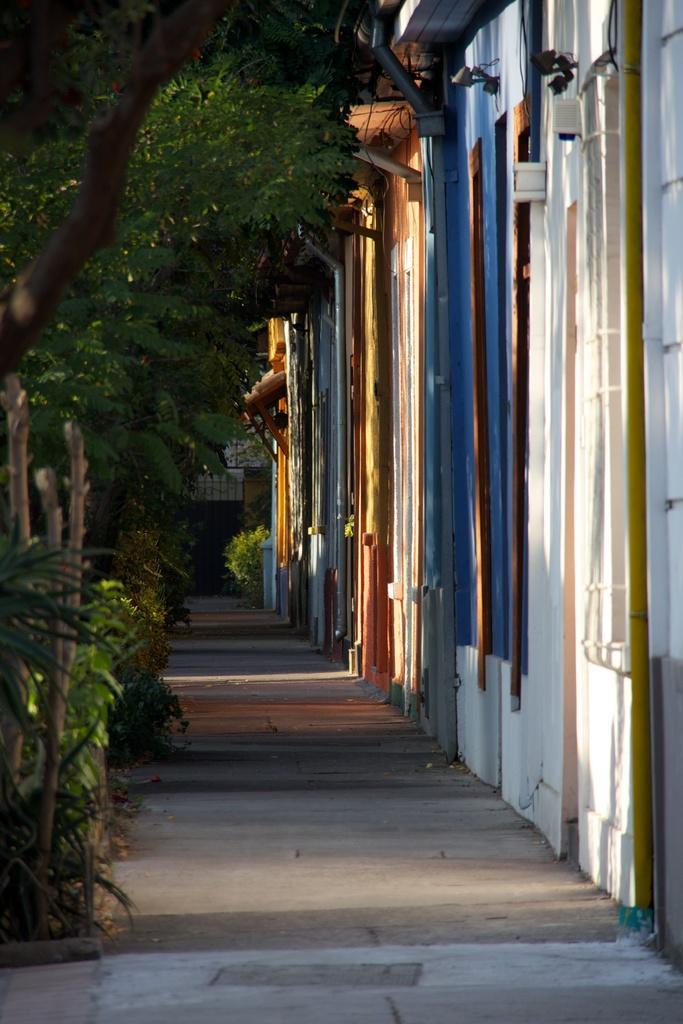Could you give a brief overview of what you see in this image? In this image we can see few buildings on the right side and few trees on the left side. 